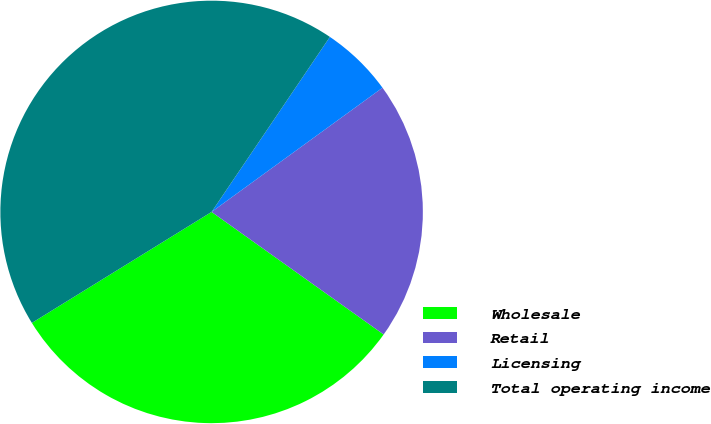<chart> <loc_0><loc_0><loc_500><loc_500><pie_chart><fcel>Wholesale<fcel>Retail<fcel>Licensing<fcel>Total operating income<nl><fcel>31.34%<fcel>19.85%<fcel>5.54%<fcel>43.26%<nl></chart> 